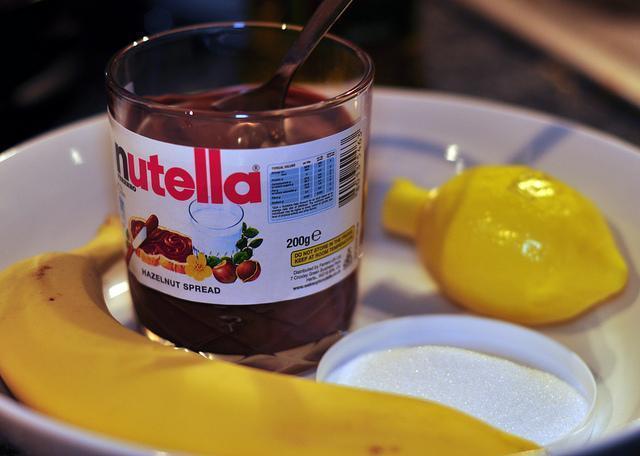How many people wear white shorts in the beach?
Give a very brief answer. 0. 